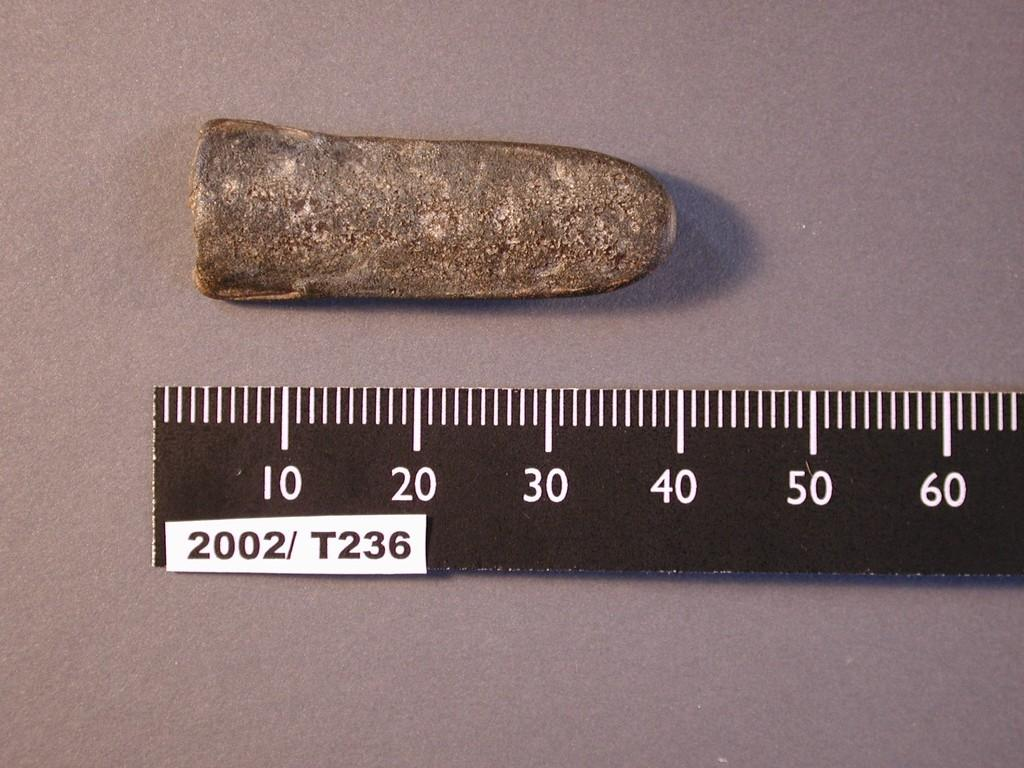What type of object is considered antique in the image? There is an antique piece in the image. What tool is visible in the image? There is a measuring scale in the image. Where are both the antique piece and the measuring scale located? Both the antique piece and the measuring scale are on the floor. Can you tell me how many goats are standing next to the antique piece in the image? There are no goats present in the image; it only features an antique piece and a measuring scale on the floor. 